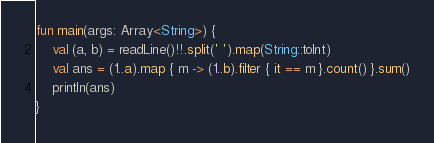Convert code to text. <code><loc_0><loc_0><loc_500><loc_500><_Kotlin_>fun main(args: Array<String>) {
    val (a, b) = readLine()!!.split(' ').map(String::toInt)
    val ans = (1..a).map { m -> (1..b).filter { it == m }.count() }.sum()
    println(ans)
}
</code> 